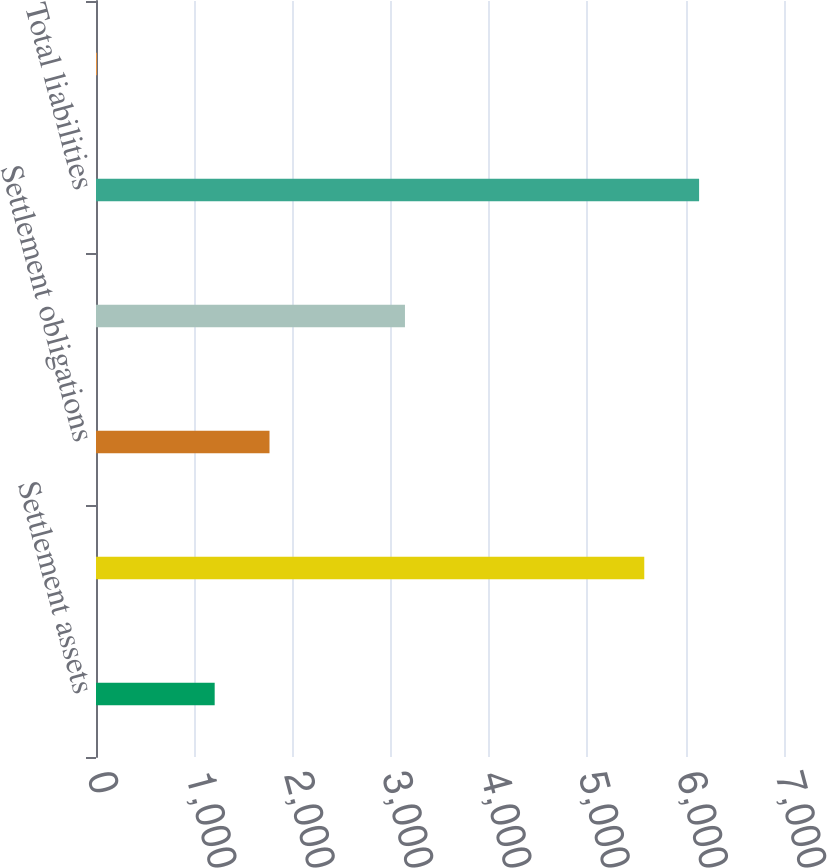Convert chart to OTSL. <chart><loc_0><loc_0><loc_500><loc_500><bar_chart><fcel>Settlement assets<fcel>Total assets<fcel>Settlement obligations<fcel>Total borrowings (o)<fcel>Total liabilities<fcel>Total stockholders'<nl><fcel>1207.5<fcel>5578.3<fcel>1765.33<fcel>3143.5<fcel>6136.13<fcel>8.1<nl></chart> 